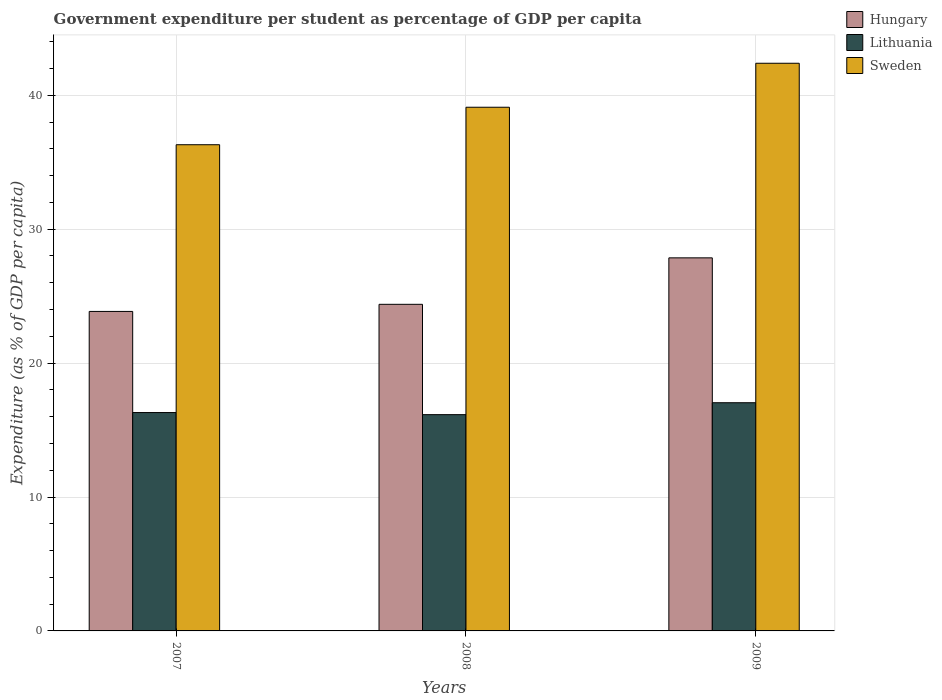How many different coloured bars are there?
Your response must be concise. 3. How many bars are there on the 1st tick from the right?
Ensure brevity in your answer.  3. What is the label of the 3rd group of bars from the left?
Ensure brevity in your answer.  2009. What is the percentage of expenditure per student in Lithuania in 2007?
Your answer should be very brief. 16.31. Across all years, what is the maximum percentage of expenditure per student in Lithuania?
Ensure brevity in your answer.  17.04. Across all years, what is the minimum percentage of expenditure per student in Lithuania?
Make the answer very short. 16.15. What is the total percentage of expenditure per student in Lithuania in the graph?
Give a very brief answer. 49.5. What is the difference between the percentage of expenditure per student in Sweden in 2007 and that in 2008?
Provide a short and direct response. -2.8. What is the difference between the percentage of expenditure per student in Sweden in 2007 and the percentage of expenditure per student in Lithuania in 2008?
Offer a terse response. 20.16. What is the average percentage of expenditure per student in Lithuania per year?
Make the answer very short. 16.5. In the year 2007, what is the difference between the percentage of expenditure per student in Sweden and percentage of expenditure per student in Lithuania?
Offer a very short reply. 20. In how many years, is the percentage of expenditure per student in Lithuania greater than 28 %?
Your answer should be compact. 0. What is the ratio of the percentage of expenditure per student in Hungary in 2007 to that in 2009?
Ensure brevity in your answer.  0.86. Is the percentage of expenditure per student in Sweden in 2008 less than that in 2009?
Ensure brevity in your answer.  Yes. What is the difference between the highest and the second highest percentage of expenditure per student in Hungary?
Ensure brevity in your answer.  3.47. What is the difference between the highest and the lowest percentage of expenditure per student in Sweden?
Provide a succinct answer. 6.08. What does the 2nd bar from the left in 2008 represents?
Your response must be concise. Lithuania. What does the 3rd bar from the right in 2009 represents?
Offer a terse response. Hungary. Is it the case that in every year, the sum of the percentage of expenditure per student in Sweden and percentage of expenditure per student in Hungary is greater than the percentage of expenditure per student in Lithuania?
Make the answer very short. Yes. What is the difference between two consecutive major ticks on the Y-axis?
Make the answer very short. 10. Are the values on the major ticks of Y-axis written in scientific E-notation?
Provide a short and direct response. No. Does the graph contain grids?
Ensure brevity in your answer.  Yes. Where does the legend appear in the graph?
Your answer should be very brief. Top right. How many legend labels are there?
Provide a succinct answer. 3. How are the legend labels stacked?
Make the answer very short. Vertical. What is the title of the graph?
Your answer should be compact. Government expenditure per student as percentage of GDP per capita. What is the label or title of the X-axis?
Provide a succinct answer. Years. What is the label or title of the Y-axis?
Keep it short and to the point. Expenditure (as % of GDP per capita). What is the Expenditure (as % of GDP per capita) of Hungary in 2007?
Offer a very short reply. 23.86. What is the Expenditure (as % of GDP per capita) in Lithuania in 2007?
Your answer should be compact. 16.31. What is the Expenditure (as % of GDP per capita) in Sweden in 2007?
Provide a short and direct response. 36.31. What is the Expenditure (as % of GDP per capita) of Hungary in 2008?
Give a very brief answer. 24.39. What is the Expenditure (as % of GDP per capita) in Lithuania in 2008?
Offer a very short reply. 16.15. What is the Expenditure (as % of GDP per capita) in Sweden in 2008?
Offer a very short reply. 39.11. What is the Expenditure (as % of GDP per capita) of Hungary in 2009?
Provide a succinct answer. 27.86. What is the Expenditure (as % of GDP per capita) in Lithuania in 2009?
Provide a succinct answer. 17.04. What is the Expenditure (as % of GDP per capita) in Sweden in 2009?
Provide a short and direct response. 42.39. Across all years, what is the maximum Expenditure (as % of GDP per capita) of Hungary?
Your answer should be compact. 27.86. Across all years, what is the maximum Expenditure (as % of GDP per capita) in Lithuania?
Provide a succinct answer. 17.04. Across all years, what is the maximum Expenditure (as % of GDP per capita) in Sweden?
Keep it short and to the point. 42.39. Across all years, what is the minimum Expenditure (as % of GDP per capita) of Hungary?
Your response must be concise. 23.86. Across all years, what is the minimum Expenditure (as % of GDP per capita) of Lithuania?
Provide a succinct answer. 16.15. Across all years, what is the minimum Expenditure (as % of GDP per capita) of Sweden?
Make the answer very short. 36.31. What is the total Expenditure (as % of GDP per capita) in Hungary in the graph?
Provide a short and direct response. 76.11. What is the total Expenditure (as % of GDP per capita) in Lithuania in the graph?
Keep it short and to the point. 49.5. What is the total Expenditure (as % of GDP per capita) in Sweden in the graph?
Make the answer very short. 117.81. What is the difference between the Expenditure (as % of GDP per capita) in Hungary in 2007 and that in 2008?
Provide a succinct answer. -0.53. What is the difference between the Expenditure (as % of GDP per capita) of Lithuania in 2007 and that in 2008?
Your answer should be compact. 0.16. What is the difference between the Expenditure (as % of GDP per capita) in Hungary in 2007 and that in 2009?
Your response must be concise. -4. What is the difference between the Expenditure (as % of GDP per capita) of Lithuania in 2007 and that in 2009?
Your answer should be compact. -0.73. What is the difference between the Expenditure (as % of GDP per capita) of Sweden in 2007 and that in 2009?
Give a very brief answer. -6.08. What is the difference between the Expenditure (as % of GDP per capita) of Hungary in 2008 and that in 2009?
Give a very brief answer. -3.47. What is the difference between the Expenditure (as % of GDP per capita) of Lithuania in 2008 and that in 2009?
Make the answer very short. -0.89. What is the difference between the Expenditure (as % of GDP per capita) of Sweden in 2008 and that in 2009?
Offer a terse response. -3.28. What is the difference between the Expenditure (as % of GDP per capita) of Hungary in 2007 and the Expenditure (as % of GDP per capita) of Lithuania in 2008?
Offer a terse response. 7.71. What is the difference between the Expenditure (as % of GDP per capita) of Hungary in 2007 and the Expenditure (as % of GDP per capita) of Sweden in 2008?
Ensure brevity in your answer.  -15.25. What is the difference between the Expenditure (as % of GDP per capita) of Lithuania in 2007 and the Expenditure (as % of GDP per capita) of Sweden in 2008?
Make the answer very short. -22.8. What is the difference between the Expenditure (as % of GDP per capita) of Hungary in 2007 and the Expenditure (as % of GDP per capita) of Lithuania in 2009?
Your answer should be compact. 6.82. What is the difference between the Expenditure (as % of GDP per capita) in Hungary in 2007 and the Expenditure (as % of GDP per capita) in Sweden in 2009?
Your response must be concise. -18.53. What is the difference between the Expenditure (as % of GDP per capita) in Lithuania in 2007 and the Expenditure (as % of GDP per capita) in Sweden in 2009?
Offer a very short reply. -26.08. What is the difference between the Expenditure (as % of GDP per capita) of Hungary in 2008 and the Expenditure (as % of GDP per capita) of Lithuania in 2009?
Provide a succinct answer. 7.35. What is the difference between the Expenditure (as % of GDP per capita) of Hungary in 2008 and the Expenditure (as % of GDP per capita) of Sweden in 2009?
Offer a terse response. -18. What is the difference between the Expenditure (as % of GDP per capita) of Lithuania in 2008 and the Expenditure (as % of GDP per capita) of Sweden in 2009?
Provide a short and direct response. -26.24. What is the average Expenditure (as % of GDP per capita) in Hungary per year?
Keep it short and to the point. 25.37. What is the average Expenditure (as % of GDP per capita) in Lithuania per year?
Your response must be concise. 16.5. What is the average Expenditure (as % of GDP per capita) in Sweden per year?
Offer a very short reply. 39.27. In the year 2007, what is the difference between the Expenditure (as % of GDP per capita) of Hungary and Expenditure (as % of GDP per capita) of Lithuania?
Offer a very short reply. 7.55. In the year 2007, what is the difference between the Expenditure (as % of GDP per capita) in Hungary and Expenditure (as % of GDP per capita) in Sweden?
Keep it short and to the point. -12.45. In the year 2007, what is the difference between the Expenditure (as % of GDP per capita) of Lithuania and Expenditure (as % of GDP per capita) of Sweden?
Give a very brief answer. -20. In the year 2008, what is the difference between the Expenditure (as % of GDP per capita) in Hungary and Expenditure (as % of GDP per capita) in Lithuania?
Offer a very short reply. 8.24. In the year 2008, what is the difference between the Expenditure (as % of GDP per capita) in Hungary and Expenditure (as % of GDP per capita) in Sweden?
Your answer should be compact. -14.72. In the year 2008, what is the difference between the Expenditure (as % of GDP per capita) of Lithuania and Expenditure (as % of GDP per capita) of Sweden?
Your answer should be compact. -22.96. In the year 2009, what is the difference between the Expenditure (as % of GDP per capita) of Hungary and Expenditure (as % of GDP per capita) of Lithuania?
Your answer should be compact. 10.82. In the year 2009, what is the difference between the Expenditure (as % of GDP per capita) of Hungary and Expenditure (as % of GDP per capita) of Sweden?
Keep it short and to the point. -14.53. In the year 2009, what is the difference between the Expenditure (as % of GDP per capita) of Lithuania and Expenditure (as % of GDP per capita) of Sweden?
Keep it short and to the point. -25.35. What is the ratio of the Expenditure (as % of GDP per capita) in Hungary in 2007 to that in 2008?
Provide a short and direct response. 0.98. What is the ratio of the Expenditure (as % of GDP per capita) of Lithuania in 2007 to that in 2008?
Provide a short and direct response. 1.01. What is the ratio of the Expenditure (as % of GDP per capita) of Sweden in 2007 to that in 2008?
Your answer should be compact. 0.93. What is the ratio of the Expenditure (as % of GDP per capita) in Hungary in 2007 to that in 2009?
Make the answer very short. 0.86. What is the ratio of the Expenditure (as % of GDP per capita) in Lithuania in 2007 to that in 2009?
Provide a short and direct response. 0.96. What is the ratio of the Expenditure (as % of GDP per capita) of Sweden in 2007 to that in 2009?
Your answer should be compact. 0.86. What is the ratio of the Expenditure (as % of GDP per capita) in Hungary in 2008 to that in 2009?
Your response must be concise. 0.88. What is the ratio of the Expenditure (as % of GDP per capita) in Lithuania in 2008 to that in 2009?
Your answer should be very brief. 0.95. What is the ratio of the Expenditure (as % of GDP per capita) in Sweden in 2008 to that in 2009?
Your answer should be very brief. 0.92. What is the difference between the highest and the second highest Expenditure (as % of GDP per capita) of Hungary?
Provide a short and direct response. 3.47. What is the difference between the highest and the second highest Expenditure (as % of GDP per capita) in Lithuania?
Offer a terse response. 0.73. What is the difference between the highest and the second highest Expenditure (as % of GDP per capita) of Sweden?
Your answer should be compact. 3.28. What is the difference between the highest and the lowest Expenditure (as % of GDP per capita) in Hungary?
Ensure brevity in your answer.  4. What is the difference between the highest and the lowest Expenditure (as % of GDP per capita) in Lithuania?
Provide a short and direct response. 0.89. What is the difference between the highest and the lowest Expenditure (as % of GDP per capita) of Sweden?
Your answer should be compact. 6.08. 